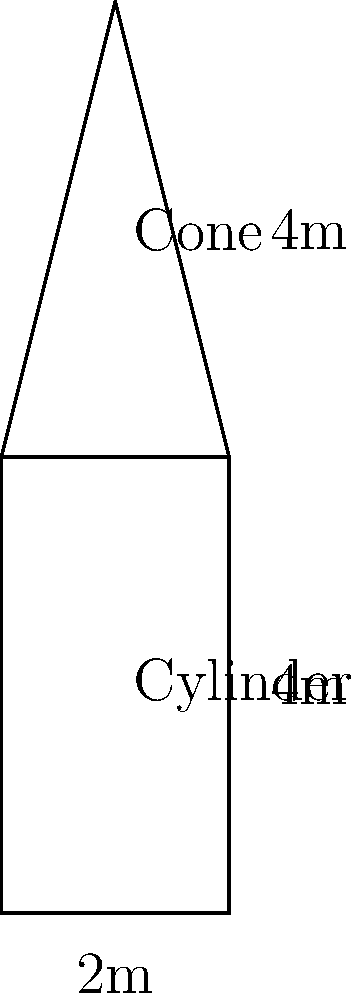As a junior deck officer, you need to estimate the total volume of a fuel storage tank composed of a cylindrical base with a conical top. The cylindrical part has a height of 4 meters and a diameter of 2 meters, while the conical part has an additional height of 4 meters. Calculate the total volume of the fuel tank in cubic meters, rounded to the nearest whole number. Let's break this down step-by-step:

1) First, calculate the volume of the cylindrical part:
   $V_{cylinder} = \pi r^2 h$
   where $r$ is the radius (1 meter) and $h$ is the height (4 meters)
   $V_{cylinder} = \pi (1^2) (4) = 4\pi$ cubic meters

2) Next, calculate the volume of the conical part:
   $V_{cone} = \frac{1}{3} \pi r^2 h$
   where $r$ is the radius (1 meter) and $h$ is the height (4 meters)
   $V_{cone} = \frac{1}{3} \pi (1^2) (4) = \frac{4}{3}\pi$ cubic meters

3) Add the volumes together:
   $V_{total} = V_{cylinder} + V_{cone}$
   $V_{total} = 4\pi + \frac{4}{3}\pi = \frac{16}{3}\pi$ cubic meters

4) Calculate the numerical value:
   $\frac{16}{3}\pi \approx 16.76$ cubic meters

5) Rounding to the nearest whole number:
   16.76 rounds to 17 cubic meters
Answer: 17 cubic meters 